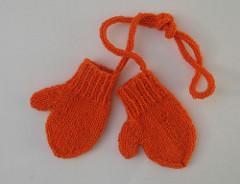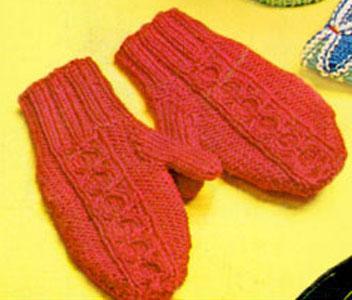The first image is the image on the left, the second image is the image on the right. For the images displayed, is the sentence "Each image contains exactly one mitten pair, and all mittens feature reddish-orange color." factually correct? Answer yes or no. Yes. The first image is the image on the left, the second image is the image on the right. Examine the images to the left and right. Is the description "There is at least one pair of gloves with the both thumb parts pointing right." accurate? Answer yes or no. No. 